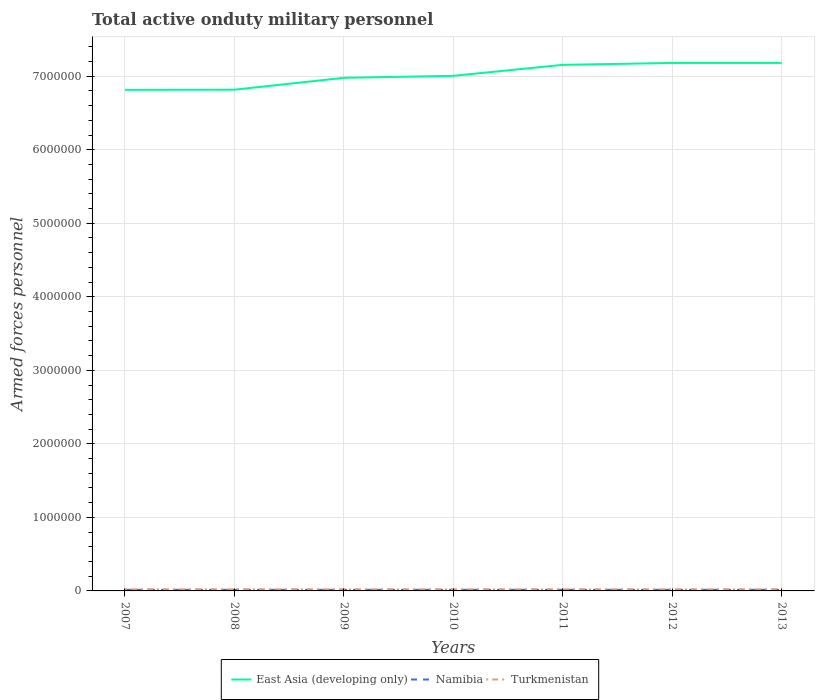Is the number of lines equal to the number of legend labels?
Ensure brevity in your answer.  Yes. Across all years, what is the maximum number of armed forces personnel in Turkmenistan?
Keep it short and to the point. 2.20e+04. In which year was the number of armed forces personnel in Turkmenistan maximum?
Your answer should be very brief. 2007. What is the total number of armed forces personnel in Turkmenistan in the graph?
Offer a terse response. 0. Is the number of armed forces personnel in Turkmenistan strictly greater than the number of armed forces personnel in Namibia over the years?
Keep it short and to the point. No. How many lines are there?
Your answer should be compact. 3. How many years are there in the graph?
Ensure brevity in your answer.  7. Where does the legend appear in the graph?
Make the answer very short. Bottom center. How many legend labels are there?
Ensure brevity in your answer.  3. What is the title of the graph?
Offer a very short reply. Total active onduty military personnel. What is the label or title of the X-axis?
Your answer should be very brief. Years. What is the label or title of the Y-axis?
Your answer should be very brief. Armed forces personnel. What is the Armed forces personnel in East Asia (developing only) in 2007?
Keep it short and to the point. 6.82e+06. What is the Armed forces personnel of Namibia in 2007?
Your response must be concise. 1.50e+04. What is the Armed forces personnel in Turkmenistan in 2007?
Your response must be concise. 2.20e+04. What is the Armed forces personnel in East Asia (developing only) in 2008?
Give a very brief answer. 6.82e+06. What is the Armed forces personnel in Namibia in 2008?
Ensure brevity in your answer.  1.50e+04. What is the Armed forces personnel of Turkmenistan in 2008?
Your answer should be compact. 2.20e+04. What is the Armed forces personnel of East Asia (developing only) in 2009?
Your response must be concise. 6.98e+06. What is the Armed forces personnel of Namibia in 2009?
Your answer should be very brief. 1.52e+04. What is the Armed forces personnel in Turkmenistan in 2009?
Ensure brevity in your answer.  2.20e+04. What is the Armed forces personnel in East Asia (developing only) in 2010?
Offer a very short reply. 7.01e+06. What is the Armed forces personnel of Namibia in 2010?
Make the answer very short. 1.52e+04. What is the Armed forces personnel of Turkmenistan in 2010?
Ensure brevity in your answer.  2.20e+04. What is the Armed forces personnel of East Asia (developing only) in 2011?
Ensure brevity in your answer.  7.15e+06. What is the Armed forces personnel of Namibia in 2011?
Your response must be concise. 1.52e+04. What is the Armed forces personnel of Turkmenistan in 2011?
Ensure brevity in your answer.  2.20e+04. What is the Armed forces personnel in East Asia (developing only) in 2012?
Your answer should be compact. 7.18e+06. What is the Armed forces personnel in Namibia in 2012?
Ensure brevity in your answer.  1.52e+04. What is the Armed forces personnel in Turkmenistan in 2012?
Ensure brevity in your answer.  2.20e+04. What is the Armed forces personnel of East Asia (developing only) in 2013?
Keep it short and to the point. 7.18e+06. What is the Armed forces personnel of Namibia in 2013?
Your answer should be very brief. 1.52e+04. What is the Armed forces personnel of Turkmenistan in 2013?
Provide a succinct answer. 2.20e+04. Across all years, what is the maximum Armed forces personnel in East Asia (developing only)?
Provide a succinct answer. 7.18e+06. Across all years, what is the maximum Armed forces personnel of Namibia?
Your answer should be very brief. 1.52e+04. Across all years, what is the maximum Armed forces personnel in Turkmenistan?
Offer a terse response. 2.20e+04. Across all years, what is the minimum Armed forces personnel in East Asia (developing only)?
Ensure brevity in your answer.  6.82e+06. Across all years, what is the minimum Armed forces personnel of Namibia?
Give a very brief answer. 1.50e+04. Across all years, what is the minimum Armed forces personnel in Turkmenistan?
Offer a terse response. 2.20e+04. What is the total Armed forces personnel of East Asia (developing only) in the graph?
Your answer should be very brief. 4.91e+07. What is the total Armed forces personnel in Namibia in the graph?
Your answer should be very brief. 1.06e+05. What is the total Armed forces personnel of Turkmenistan in the graph?
Give a very brief answer. 1.54e+05. What is the difference between the Armed forces personnel in East Asia (developing only) in 2007 and that in 2008?
Offer a very short reply. -2000. What is the difference between the Armed forces personnel in Namibia in 2007 and that in 2008?
Your response must be concise. 0. What is the difference between the Armed forces personnel of Turkmenistan in 2007 and that in 2008?
Offer a terse response. 0. What is the difference between the Armed forces personnel in East Asia (developing only) in 2007 and that in 2009?
Make the answer very short. -1.63e+05. What is the difference between the Armed forces personnel of Namibia in 2007 and that in 2009?
Make the answer very short. -200. What is the difference between the Armed forces personnel in Turkmenistan in 2007 and that in 2009?
Keep it short and to the point. 0. What is the difference between the Armed forces personnel of East Asia (developing only) in 2007 and that in 2010?
Your answer should be very brief. -1.90e+05. What is the difference between the Armed forces personnel of Namibia in 2007 and that in 2010?
Your answer should be compact. -200. What is the difference between the Armed forces personnel of East Asia (developing only) in 2007 and that in 2011?
Your answer should be compact. -3.40e+05. What is the difference between the Armed forces personnel of Namibia in 2007 and that in 2011?
Your answer should be compact. -200. What is the difference between the Armed forces personnel of Turkmenistan in 2007 and that in 2011?
Offer a terse response. 0. What is the difference between the Armed forces personnel in East Asia (developing only) in 2007 and that in 2012?
Give a very brief answer. -3.66e+05. What is the difference between the Armed forces personnel of Namibia in 2007 and that in 2012?
Your answer should be compact. -200. What is the difference between the Armed forces personnel of Turkmenistan in 2007 and that in 2012?
Your answer should be very brief. 0. What is the difference between the Armed forces personnel in East Asia (developing only) in 2007 and that in 2013?
Your answer should be very brief. -3.66e+05. What is the difference between the Armed forces personnel of Namibia in 2007 and that in 2013?
Your answer should be very brief. -200. What is the difference between the Armed forces personnel of East Asia (developing only) in 2008 and that in 2009?
Provide a short and direct response. -1.61e+05. What is the difference between the Armed forces personnel in Namibia in 2008 and that in 2009?
Your answer should be compact. -200. What is the difference between the Armed forces personnel in East Asia (developing only) in 2008 and that in 2010?
Keep it short and to the point. -1.88e+05. What is the difference between the Armed forces personnel in Namibia in 2008 and that in 2010?
Your answer should be very brief. -200. What is the difference between the Armed forces personnel in Turkmenistan in 2008 and that in 2010?
Offer a terse response. 0. What is the difference between the Armed forces personnel in East Asia (developing only) in 2008 and that in 2011?
Offer a very short reply. -3.38e+05. What is the difference between the Armed forces personnel of Namibia in 2008 and that in 2011?
Provide a short and direct response. -200. What is the difference between the Armed forces personnel of East Asia (developing only) in 2008 and that in 2012?
Offer a very short reply. -3.64e+05. What is the difference between the Armed forces personnel in Namibia in 2008 and that in 2012?
Your answer should be compact. -200. What is the difference between the Armed forces personnel in East Asia (developing only) in 2008 and that in 2013?
Provide a short and direct response. -3.64e+05. What is the difference between the Armed forces personnel in Namibia in 2008 and that in 2013?
Provide a short and direct response. -200. What is the difference between the Armed forces personnel in Turkmenistan in 2008 and that in 2013?
Your response must be concise. 0. What is the difference between the Armed forces personnel of East Asia (developing only) in 2009 and that in 2010?
Provide a succinct answer. -2.70e+04. What is the difference between the Armed forces personnel of Turkmenistan in 2009 and that in 2010?
Offer a very short reply. 0. What is the difference between the Armed forces personnel of East Asia (developing only) in 2009 and that in 2011?
Make the answer very short. -1.76e+05. What is the difference between the Armed forces personnel in Turkmenistan in 2009 and that in 2011?
Your answer should be very brief. 0. What is the difference between the Armed forces personnel of East Asia (developing only) in 2009 and that in 2012?
Your response must be concise. -2.02e+05. What is the difference between the Armed forces personnel in Namibia in 2009 and that in 2012?
Your response must be concise. 0. What is the difference between the Armed forces personnel in East Asia (developing only) in 2009 and that in 2013?
Make the answer very short. -2.03e+05. What is the difference between the Armed forces personnel in Turkmenistan in 2009 and that in 2013?
Your response must be concise. 0. What is the difference between the Armed forces personnel in East Asia (developing only) in 2010 and that in 2011?
Give a very brief answer. -1.49e+05. What is the difference between the Armed forces personnel in East Asia (developing only) in 2010 and that in 2012?
Your answer should be compact. -1.75e+05. What is the difference between the Armed forces personnel in East Asia (developing only) in 2010 and that in 2013?
Provide a short and direct response. -1.76e+05. What is the difference between the Armed forces personnel in Namibia in 2010 and that in 2013?
Give a very brief answer. 0. What is the difference between the Armed forces personnel of East Asia (developing only) in 2011 and that in 2012?
Provide a short and direct response. -2.58e+04. What is the difference between the Armed forces personnel of Turkmenistan in 2011 and that in 2012?
Your answer should be very brief. 0. What is the difference between the Armed forces personnel of East Asia (developing only) in 2011 and that in 2013?
Offer a very short reply. -2.61e+04. What is the difference between the Armed forces personnel of East Asia (developing only) in 2012 and that in 2013?
Your response must be concise. -300. What is the difference between the Armed forces personnel in Namibia in 2012 and that in 2013?
Your response must be concise. 0. What is the difference between the Armed forces personnel in Turkmenistan in 2012 and that in 2013?
Your answer should be compact. 0. What is the difference between the Armed forces personnel in East Asia (developing only) in 2007 and the Armed forces personnel in Namibia in 2008?
Offer a terse response. 6.80e+06. What is the difference between the Armed forces personnel in East Asia (developing only) in 2007 and the Armed forces personnel in Turkmenistan in 2008?
Make the answer very short. 6.79e+06. What is the difference between the Armed forces personnel in Namibia in 2007 and the Armed forces personnel in Turkmenistan in 2008?
Ensure brevity in your answer.  -7000. What is the difference between the Armed forces personnel in East Asia (developing only) in 2007 and the Armed forces personnel in Namibia in 2009?
Offer a very short reply. 6.80e+06. What is the difference between the Armed forces personnel of East Asia (developing only) in 2007 and the Armed forces personnel of Turkmenistan in 2009?
Your answer should be very brief. 6.79e+06. What is the difference between the Armed forces personnel in Namibia in 2007 and the Armed forces personnel in Turkmenistan in 2009?
Ensure brevity in your answer.  -7000. What is the difference between the Armed forces personnel of East Asia (developing only) in 2007 and the Armed forces personnel of Namibia in 2010?
Give a very brief answer. 6.80e+06. What is the difference between the Armed forces personnel of East Asia (developing only) in 2007 and the Armed forces personnel of Turkmenistan in 2010?
Provide a short and direct response. 6.79e+06. What is the difference between the Armed forces personnel in Namibia in 2007 and the Armed forces personnel in Turkmenistan in 2010?
Offer a very short reply. -7000. What is the difference between the Armed forces personnel of East Asia (developing only) in 2007 and the Armed forces personnel of Namibia in 2011?
Make the answer very short. 6.80e+06. What is the difference between the Armed forces personnel of East Asia (developing only) in 2007 and the Armed forces personnel of Turkmenistan in 2011?
Provide a succinct answer. 6.79e+06. What is the difference between the Armed forces personnel in Namibia in 2007 and the Armed forces personnel in Turkmenistan in 2011?
Provide a short and direct response. -7000. What is the difference between the Armed forces personnel in East Asia (developing only) in 2007 and the Armed forces personnel in Namibia in 2012?
Give a very brief answer. 6.80e+06. What is the difference between the Armed forces personnel of East Asia (developing only) in 2007 and the Armed forces personnel of Turkmenistan in 2012?
Keep it short and to the point. 6.79e+06. What is the difference between the Armed forces personnel in Namibia in 2007 and the Armed forces personnel in Turkmenistan in 2012?
Your response must be concise. -7000. What is the difference between the Armed forces personnel of East Asia (developing only) in 2007 and the Armed forces personnel of Namibia in 2013?
Your response must be concise. 6.80e+06. What is the difference between the Armed forces personnel of East Asia (developing only) in 2007 and the Armed forces personnel of Turkmenistan in 2013?
Your answer should be very brief. 6.79e+06. What is the difference between the Armed forces personnel of Namibia in 2007 and the Armed forces personnel of Turkmenistan in 2013?
Give a very brief answer. -7000. What is the difference between the Armed forces personnel in East Asia (developing only) in 2008 and the Armed forces personnel in Namibia in 2009?
Ensure brevity in your answer.  6.80e+06. What is the difference between the Armed forces personnel in East Asia (developing only) in 2008 and the Armed forces personnel in Turkmenistan in 2009?
Provide a succinct answer. 6.80e+06. What is the difference between the Armed forces personnel of Namibia in 2008 and the Armed forces personnel of Turkmenistan in 2009?
Offer a very short reply. -7000. What is the difference between the Armed forces personnel in East Asia (developing only) in 2008 and the Armed forces personnel in Namibia in 2010?
Your response must be concise. 6.80e+06. What is the difference between the Armed forces personnel of East Asia (developing only) in 2008 and the Armed forces personnel of Turkmenistan in 2010?
Keep it short and to the point. 6.80e+06. What is the difference between the Armed forces personnel in Namibia in 2008 and the Armed forces personnel in Turkmenistan in 2010?
Your answer should be compact. -7000. What is the difference between the Armed forces personnel of East Asia (developing only) in 2008 and the Armed forces personnel of Namibia in 2011?
Make the answer very short. 6.80e+06. What is the difference between the Armed forces personnel of East Asia (developing only) in 2008 and the Armed forces personnel of Turkmenistan in 2011?
Your response must be concise. 6.80e+06. What is the difference between the Armed forces personnel in Namibia in 2008 and the Armed forces personnel in Turkmenistan in 2011?
Give a very brief answer. -7000. What is the difference between the Armed forces personnel of East Asia (developing only) in 2008 and the Armed forces personnel of Namibia in 2012?
Your answer should be compact. 6.80e+06. What is the difference between the Armed forces personnel of East Asia (developing only) in 2008 and the Armed forces personnel of Turkmenistan in 2012?
Provide a succinct answer. 6.80e+06. What is the difference between the Armed forces personnel of Namibia in 2008 and the Armed forces personnel of Turkmenistan in 2012?
Ensure brevity in your answer.  -7000. What is the difference between the Armed forces personnel of East Asia (developing only) in 2008 and the Armed forces personnel of Namibia in 2013?
Give a very brief answer. 6.80e+06. What is the difference between the Armed forces personnel of East Asia (developing only) in 2008 and the Armed forces personnel of Turkmenistan in 2013?
Provide a succinct answer. 6.80e+06. What is the difference between the Armed forces personnel of Namibia in 2008 and the Armed forces personnel of Turkmenistan in 2013?
Provide a succinct answer. -7000. What is the difference between the Armed forces personnel of East Asia (developing only) in 2009 and the Armed forces personnel of Namibia in 2010?
Give a very brief answer. 6.96e+06. What is the difference between the Armed forces personnel in East Asia (developing only) in 2009 and the Armed forces personnel in Turkmenistan in 2010?
Give a very brief answer. 6.96e+06. What is the difference between the Armed forces personnel in Namibia in 2009 and the Armed forces personnel in Turkmenistan in 2010?
Offer a terse response. -6800. What is the difference between the Armed forces personnel of East Asia (developing only) in 2009 and the Armed forces personnel of Namibia in 2011?
Keep it short and to the point. 6.96e+06. What is the difference between the Armed forces personnel of East Asia (developing only) in 2009 and the Armed forces personnel of Turkmenistan in 2011?
Offer a terse response. 6.96e+06. What is the difference between the Armed forces personnel in Namibia in 2009 and the Armed forces personnel in Turkmenistan in 2011?
Make the answer very short. -6800. What is the difference between the Armed forces personnel in East Asia (developing only) in 2009 and the Armed forces personnel in Namibia in 2012?
Offer a terse response. 6.96e+06. What is the difference between the Armed forces personnel of East Asia (developing only) in 2009 and the Armed forces personnel of Turkmenistan in 2012?
Offer a terse response. 6.96e+06. What is the difference between the Armed forces personnel of Namibia in 2009 and the Armed forces personnel of Turkmenistan in 2012?
Provide a succinct answer. -6800. What is the difference between the Armed forces personnel of East Asia (developing only) in 2009 and the Armed forces personnel of Namibia in 2013?
Give a very brief answer. 6.96e+06. What is the difference between the Armed forces personnel of East Asia (developing only) in 2009 and the Armed forces personnel of Turkmenistan in 2013?
Offer a terse response. 6.96e+06. What is the difference between the Armed forces personnel in Namibia in 2009 and the Armed forces personnel in Turkmenistan in 2013?
Keep it short and to the point. -6800. What is the difference between the Armed forces personnel of East Asia (developing only) in 2010 and the Armed forces personnel of Namibia in 2011?
Your response must be concise. 6.99e+06. What is the difference between the Armed forces personnel in East Asia (developing only) in 2010 and the Armed forces personnel in Turkmenistan in 2011?
Keep it short and to the point. 6.98e+06. What is the difference between the Armed forces personnel in Namibia in 2010 and the Armed forces personnel in Turkmenistan in 2011?
Keep it short and to the point. -6800. What is the difference between the Armed forces personnel in East Asia (developing only) in 2010 and the Armed forces personnel in Namibia in 2012?
Provide a succinct answer. 6.99e+06. What is the difference between the Armed forces personnel in East Asia (developing only) in 2010 and the Armed forces personnel in Turkmenistan in 2012?
Offer a very short reply. 6.98e+06. What is the difference between the Armed forces personnel in Namibia in 2010 and the Armed forces personnel in Turkmenistan in 2012?
Your answer should be very brief. -6800. What is the difference between the Armed forces personnel of East Asia (developing only) in 2010 and the Armed forces personnel of Namibia in 2013?
Your answer should be compact. 6.99e+06. What is the difference between the Armed forces personnel of East Asia (developing only) in 2010 and the Armed forces personnel of Turkmenistan in 2013?
Ensure brevity in your answer.  6.98e+06. What is the difference between the Armed forces personnel of Namibia in 2010 and the Armed forces personnel of Turkmenistan in 2013?
Your answer should be very brief. -6800. What is the difference between the Armed forces personnel in East Asia (developing only) in 2011 and the Armed forces personnel in Namibia in 2012?
Keep it short and to the point. 7.14e+06. What is the difference between the Armed forces personnel of East Asia (developing only) in 2011 and the Armed forces personnel of Turkmenistan in 2012?
Your answer should be very brief. 7.13e+06. What is the difference between the Armed forces personnel of Namibia in 2011 and the Armed forces personnel of Turkmenistan in 2012?
Provide a short and direct response. -6800. What is the difference between the Armed forces personnel in East Asia (developing only) in 2011 and the Armed forces personnel in Namibia in 2013?
Keep it short and to the point. 7.14e+06. What is the difference between the Armed forces personnel in East Asia (developing only) in 2011 and the Armed forces personnel in Turkmenistan in 2013?
Make the answer very short. 7.13e+06. What is the difference between the Armed forces personnel of Namibia in 2011 and the Armed forces personnel of Turkmenistan in 2013?
Your response must be concise. -6800. What is the difference between the Armed forces personnel in East Asia (developing only) in 2012 and the Armed forces personnel in Namibia in 2013?
Your answer should be very brief. 7.17e+06. What is the difference between the Armed forces personnel of East Asia (developing only) in 2012 and the Armed forces personnel of Turkmenistan in 2013?
Your answer should be very brief. 7.16e+06. What is the difference between the Armed forces personnel of Namibia in 2012 and the Armed forces personnel of Turkmenistan in 2013?
Your response must be concise. -6800. What is the average Armed forces personnel of East Asia (developing only) per year?
Offer a terse response. 7.02e+06. What is the average Armed forces personnel in Namibia per year?
Offer a terse response. 1.51e+04. What is the average Armed forces personnel in Turkmenistan per year?
Give a very brief answer. 2.20e+04. In the year 2007, what is the difference between the Armed forces personnel of East Asia (developing only) and Armed forces personnel of Namibia?
Provide a short and direct response. 6.80e+06. In the year 2007, what is the difference between the Armed forces personnel of East Asia (developing only) and Armed forces personnel of Turkmenistan?
Your response must be concise. 6.79e+06. In the year 2007, what is the difference between the Armed forces personnel in Namibia and Armed forces personnel in Turkmenistan?
Your answer should be compact. -7000. In the year 2008, what is the difference between the Armed forces personnel in East Asia (developing only) and Armed forces personnel in Namibia?
Keep it short and to the point. 6.80e+06. In the year 2008, what is the difference between the Armed forces personnel of East Asia (developing only) and Armed forces personnel of Turkmenistan?
Your answer should be compact. 6.80e+06. In the year 2008, what is the difference between the Armed forces personnel in Namibia and Armed forces personnel in Turkmenistan?
Your answer should be very brief. -7000. In the year 2009, what is the difference between the Armed forces personnel in East Asia (developing only) and Armed forces personnel in Namibia?
Your response must be concise. 6.96e+06. In the year 2009, what is the difference between the Armed forces personnel in East Asia (developing only) and Armed forces personnel in Turkmenistan?
Provide a short and direct response. 6.96e+06. In the year 2009, what is the difference between the Armed forces personnel of Namibia and Armed forces personnel of Turkmenistan?
Keep it short and to the point. -6800. In the year 2010, what is the difference between the Armed forces personnel in East Asia (developing only) and Armed forces personnel in Namibia?
Give a very brief answer. 6.99e+06. In the year 2010, what is the difference between the Armed forces personnel in East Asia (developing only) and Armed forces personnel in Turkmenistan?
Your answer should be compact. 6.98e+06. In the year 2010, what is the difference between the Armed forces personnel in Namibia and Armed forces personnel in Turkmenistan?
Offer a terse response. -6800. In the year 2011, what is the difference between the Armed forces personnel in East Asia (developing only) and Armed forces personnel in Namibia?
Keep it short and to the point. 7.14e+06. In the year 2011, what is the difference between the Armed forces personnel in East Asia (developing only) and Armed forces personnel in Turkmenistan?
Give a very brief answer. 7.13e+06. In the year 2011, what is the difference between the Armed forces personnel of Namibia and Armed forces personnel of Turkmenistan?
Give a very brief answer. -6800. In the year 2012, what is the difference between the Armed forces personnel of East Asia (developing only) and Armed forces personnel of Namibia?
Offer a terse response. 7.17e+06. In the year 2012, what is the difference between the Armed forces personnel of East Asia (developing only) and Armed forces personnel of Turkmenistan?
Your response must be concise. 7.16e+06. In the year 2012, what is the difference between the Armed forces personnel in Namibia and Armed forces personnel in Turkmenistan?
Offer a terse response. -6800. In the year 2013, what is the difference between the Armed forces personnel of East Asia (developing only) and Armed forces personnel of Namibia?
Offer a very short reply. 7.17e+06. In the year 2013, what is the difference between the Armed forces personnel of East Asia (developing only) and Armed forces personnel of Turkmenistan?
Your response must be concise. 7.16e+06. In the year 2013, what is the difference between the Armed forces personnel in Namibia and Armed forces personnel in Turkmenistan?
Provide a short and direct response. -6800. What is the ratio of the Armed forces personnel of East Asia (developing only) in 2007 to that in 2008?
Offer a very short reply. 1. What is the ratio of the Armed forces personnel of Namibia in 2007 to that in 2008?
Offer a terse response. 1. What is the ratio of the Armed forces personnel of Turkmenistan in 2007 to that in 2008?
Your answer should be very brief. 1. What is the ratio of the Armed forces personnel in East Asia (developing only) in 2007 to that in 2009?
Provide a short and direct response. 0.98. What is the ratio of the Armed forces personnel in East Asia (developing only) in 2007 to that in 2010?
Make the answer very short. 0.97. What is the ratio of the Armed forces personnel of East Asia (developing only) in 2007 to that in 2011?
Your response must be concise. 0.95. What is the ratio of the Armed forces personnel in Namibia in 2007 to that in 2011?
Your response must be concise. 0.99. What is the ratio of the Armed forces personnel of East Asia (developing only) in 2007 to that in 2012?
Your answer should be very brief. 0.95. What is the ratio of the Armed forces personnel of Namibia in 2007 to that in 2012?
Ensure brevity in your answer.  0.99. What is the ratio of the Armed forces personnel in East Asia (developing only) in 2007 to that in 2013?
Offer a terse response. 0.95. What is the ratio of the Armed forces personnel of Namibia in 2007 to that in 2013?
Make the answer very short. 0.99. What is the ratio of the Armed forces personnel of East Asia (developing only) in 2008 to that in 2009?
Your answer should be compact. 0.98. What is the ratio of the Armed forces personnel in East Asia (developing only) in 2008 to that in 2010?
Offer a very short reply. 0.97. What is the ratio of the Armed forces personnel in Namibia in 2008 to that in 2010?
Your answer should be very brief. 0.99. What is the ratio of the Armed forces personnel in East Asia (developing only) in 2008 to that in 2011?
Your answer should be compact. 0.95. What is the ratio of the Armed forces personnel of Namibia in 2008 to that in 2011?
Provide a short and direct response. 0.99. What is the ratio of the Armed forces personnel in Turkmenistan in 2008 to that in 2011?
Your answer should be compact. 1. What is the ratio of the Armed forces personnel of East Asia (developing only) in 2008 to that in 2012?
Ensure brevity in your answer.  0.95. What is the ratio of the Armed forces personnel of Namibia in 2008 to that in 2012?
Make the answer very short. 0.99. What is the ratio of the Armed forces personnel of East Asia (developing only) in 2008 to that in 2013?
Your response must be concise. 0.95. What is the ratio of the Armed forces personnel in Turkmenistan in 2008 to that in 2013?
Provide a succinct answer. 1. What is the ratio of the Armed forces personnel in Namibia in 2009 to that in 2010?
Give a very brief answer. 1. What is the ratio of the Armed forces personnel of East Asia (developing only) in 2009 to that in 2011?
Keep it short and to the point. 0.98. What is the ratio of the Armed forces personnel in Namibia in 2009 to that in 2011?
Make the answer very short. 1. What is the ratio of the Armed forces personnel of Turkmenistan in 2009 to that in 2011?
Your response must be concise. 1. What is the ratio of the Armed forces personnel in East Asia (developing only) in 2009 to that in 2012?
Your response must be concise. 0.97. What is the ratio of the Armed forces personnel in Namibia in 2009 to that in 2012?
Give a very brief answer. 1. What is the ratio of the Armed forces personnel in Turkmenistan in 2009 to that in 2012?
Your answer should be compact. 1. What is the ratio of the Armed forces personnel of East Asia (developing only) in 2009 to that in 2013?
Ensure brevity in your answer.  0.97. What is the ratio of the Armed forces personnel in Namibia in 2009 to that in 2013?
Your answer should be compact. 1. What is the ratio of the Armed forces personnel in Turkmenistan in 2009 to that in 2013?
Provide a short and direct response. 1. What is the ratio of the Armed forces personnel of East Asia (developing only) in 2010 to that in 2011?
Offer a terse response. 0.98. What is the ratio of the Armed forces personnel of East Asia (developing only) in 2010 to that in 2012?
Provide a short and direct response. 0.98. What is the ratio of the Armed forces personnel of Turkmenistan in 2010 to that in 2012?
Your answer should be very brief. 1. What is the ratio of the Armed forces personnel of East Asia (developing only) in 2010 to that in 2013?
Ensure brevity in your answer.  0.98. What is the ratio of the Armed forces personnel of Namibia in 2010 to that in 2013?
Your response must be concise. 1. What is the ratio of the Armed forces personnel of Namibia in 2011 to that in 2012?
Ensure brevity in your answer.  1. What is the ratio of the Armed forces personnel of Turkmenistan in 2011 to that in 2012?
Give a very brief answer. 1. What is the ratio of the Armed forces personnel in Namibia in 2011 to that in 2013?
Provide a succinct answer. 1. What is the ratio of the Armed forces personnel in Namibia in 2012 to that in 2013?
Give a very brief answer. 1. What is the ratio of the Armed forces personnel in Turkmenistan in 2012 to that in 2013?
Keep it short and to the point. 1. What is the difference between the highest and the second highest Armed forces personnel in East Asia (developing only)?
Offer a very short reply. 300. What is the difference between the highest and the second highest Armed forces personnel of Turkmenistan?
Provide a succinct answer. 0. What is the difference between the highest and the lowest Armed forces personnel of East Asia (developing only)?
Provide a short and direct response. 3.66e+05. What is the difference between the highest and the lowest Armed forces personnel of Turkmenistan?
Offer a terse response. 0. 